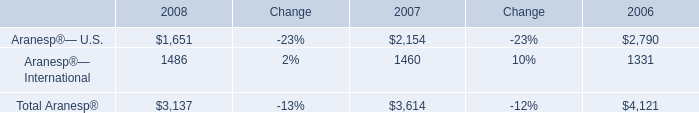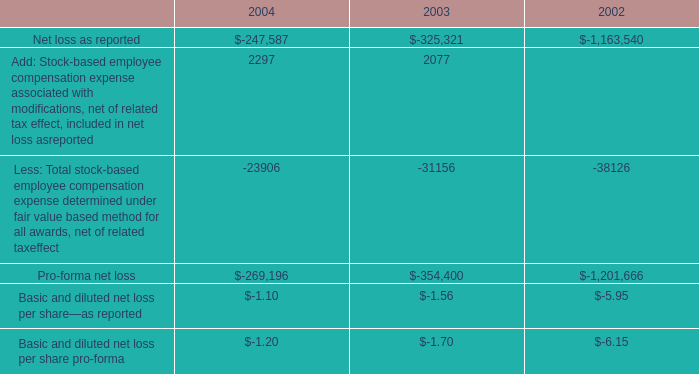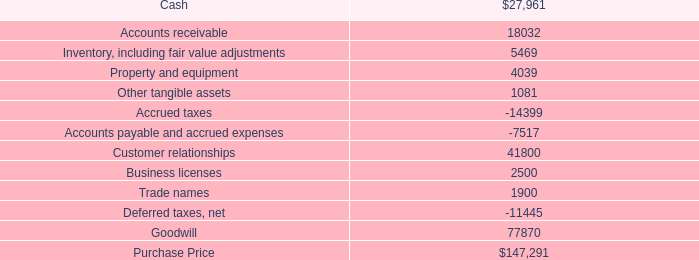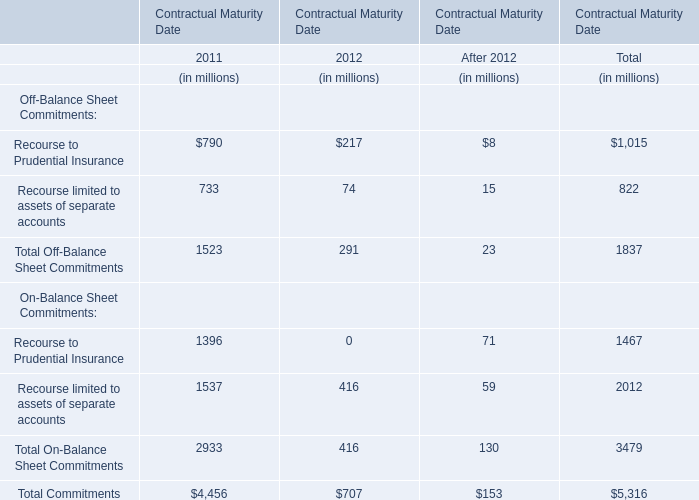what was the percentage increase in the employee contribution from 2002 to 2003 
Computations: ((825000 - 979000) / 979000)
Answer: -0.1573. 